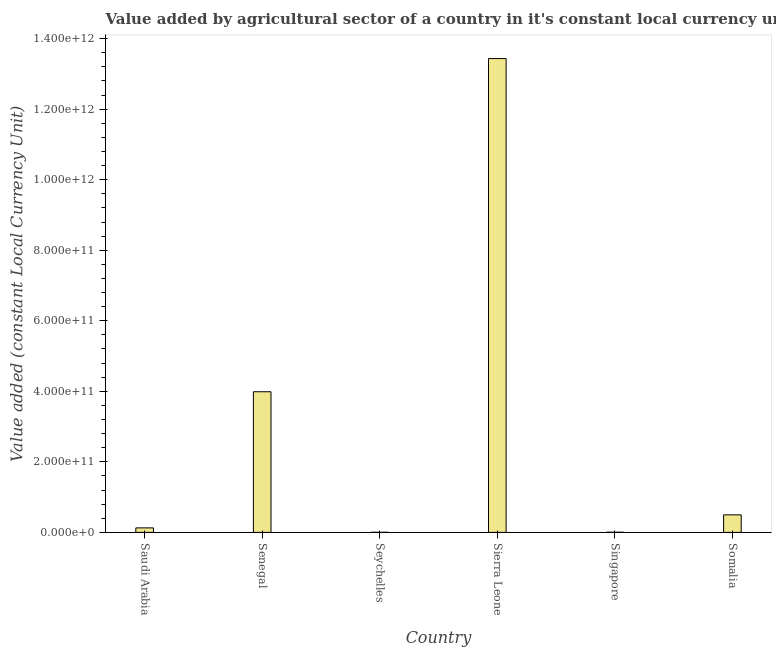Does the graph contain grids?
Ensure brevity in your answer.  No. What is the title of the graph?
Give a very brief answer. Value added by agricultural sector of a country in it's constant local currency unit. What is the label or title of the Y-axis?
Make the answer very short. Value added (constant Local Currency Unit). What is the value added by agriculture sector in Saudi Arabia?
Offer a very short reply. 1.28e+1. Across all countries, what is the maximum value added by agriculture sector?
Provide a short and direct response. 1.34e+12. Across all countries, what is the minimum value added by agriculture sector?
Give a very brief answer. 2.02e+08. In which country was the value added by agriculture sector maximum?
Make the answer very short. Sierra Leone. In which country was the value added by agriculture sector minimum?
Keep it short and to the point. Seychelles. What is the sum of the value added by agriculture sector?
Ensure brevity in your answer.  1.81e+12. What is the difference between the value added by agriculture sector in Seychelles and Somalia?
Give a very brief answer. -4.96e+1. What is the average value added by agriculture sector per country?
Keep it short and to the point. 3.01e+11. What is the median value added by agriculture sector?
Your answer should be compact. 3.13e+1. In how many countries, is the value added by agriculture sector greater than 640000000000 LCU?
Keep it short and to the point. 1. What is the ratio of the value added by agriculture sector in Senegal to that in Singapore?
Your response must be concise. 1001.45. What is the difference between the highest and the second highest value added by agriculture sector?
Give a very brief answer. 9.45e+11. What is the difference between the highest and the lowest value added by agriculture sector?
Offer a terse response. 1.34e+12. In how many countries, is the value added by agriculture sector greater than the average value added by agriculture sector taken over all countries?
Your response must be concise. 2. How many countries are there in the graph?
Keep it short and to the point. 6. What is the difference between two consecutive major ticks on the Y-axis?
Offer a very short reply. 2.00e+11. What is the Value added (constant Local Currency Unit) in Saudi Arabia?
Provide a short and direct response. 1.28e+1. What is the Value added (constant Local Currency Unit) in Senegal?
Ensure brevity in your answer.  3.99e+11. What is the Value added (constant Local Currency Unit) in Seychelles?
Your answer should be compact. 2.02e+08. What is the Value added (constant Local Currency Unit) in Sierra Leone?
Keep it short and to the point. 1.34e+12. What is the Value added (constant Local Currency Unit) in Singapore?
Provide a succinct answer. 3.98e+08. What is the Value added (constant Local Currency Unit) of Somalia?
Ensure brevity in your answer.  4.98e+1. What is the difference between the Value added (constant Local Currency Unit) in Saudi Arabia and Senegal?
Make the answer very short. -3.86e+11. What is the difference between the Value added (constant Local Currency Unit) in Saudi Arabia and Seychelles?
Make the answer very short. 1.26e+1. What is the difference between the Value added (constant Local Currency Unit) in Saudi Arabia and Sierra Leone?
Make the answer very short. -1.33e+12. What is the difference between the Value added (constant Local Currency Unit) in Saudi Arabia and Singapore?
Provide a short and direct response. 1.24e+1. What is the difference between the Value added (constant Local Currency Unit) in Saudi Arabia and Somalia?
Offer a very short reply. -3.70e+1. What is the difference between the Value added (constant Local Currency Unit) in Senegal and Seychelles?
Make the answer very short. 3.99e+11. What is the difference between the Value added (constant Local Currency Unit) in Senegal and Sierra Leone?
Provide a short and direct response. -9.45e+11. What is the difference between the Value added (constant Local Currency Unit) in Senegal and Singapore?
Offer a very short reply. 3.98e+11. What is the difference between the Value added (constant Local Currency Unit) in Senegal and Somalia?
Ensure brevity in your answer.  3.49e+11. What is the difference between the Value added (constant Local Currency Unit) in Seychelles and Sierra Leone?
Make the answer very short. -1.34e+12. What is the difference between the Value added (constant Local Currency Unit) in Seychelles and Singapore?
Provide a succinct answer. -1.96e+08. What is the difference between the Value added (constant Local Currency Unit) in Seychelles and Somalia?
Keep it short and to the point. -4.96e+1. What is the difference between the Value added (constant Local Currency Unit) in Sierra Leone and Singapore?
Make the answer very short. 1.34e+12. What is the difference between the Value added (constant Local Currency Unit) in Sierra Leone and Somalia?
Provide a short and direct response. 1.29e+12. What is the difference between the Value added (constant Local Currency Unit) in Singapore and Somalia?
Make the answer very short. -4.94e+1. What is the ratio of the Value added (constant Local Currency Unit) in Saudi Arabia to that in Senegal?
Make the answer very short. 0.03. What is the ratio of the Value added (constant Local Currency Unit) in Saudi Arabia to that in Seychelles?
Provide a short and direct response. 63.09. What is the ratio of the Value added (constant Local Currency Unit) in Saudi Arabia to that in Sierra Leone?
Your answer should be compact. 0.01. What is the ratio of the Value added (constant Local Currency Unit) in Saudi Arabia to that in Singapore?
Ensure brevity in your answer.  32.05. What is the ratio of the Value added (constant Local Currency Unit) in Saudi Arabia to that in Somalia?
Keep it short and to the point. 0.26. What is the ratio of the Value added (constant Local Currency Unit) in Senegal to that in Seychelles?
Your answer should be very brief. 1971.56. What is the ratio of the Value added (constant Local Currency Unit) in Senegal to that in Sierra Leone?
Your answer should be compact. 0.3. What is the ratio of the Value added (constant Local Currency Unit) in Senegal to that in Singapore?
Your answer should be very brief. 1001.45. What is the ratio of the Value added (constant Local Currency Unit) in Senegal to that in Somalia?
Keep it short and to the point. 8.01. What is the ratio of the Value added (constant Local Currency Unit) in Seychelles to that in Singapore?
Offer a terse response. 0.51. What is the ratio of the Value added (constant Local Currency Unit) in Seychelles to that in Somalia?
Ensure brevity in your answer.  0. What is the ratio of the Value added (constant Local Currency Unit) in Sierra Leone to that in Singapore?
Provide a short and direct response. 3373.94. What is the ratio of the Value added (constant Local Currency Unit) in Sierra Leone to that in Somalia?
Provide a succinct answer. 27. What is the ratio of the Value added (constant Local Currency Unit) in Singapore to that in Somalia?
Provide a succinct answer. 0.01. 